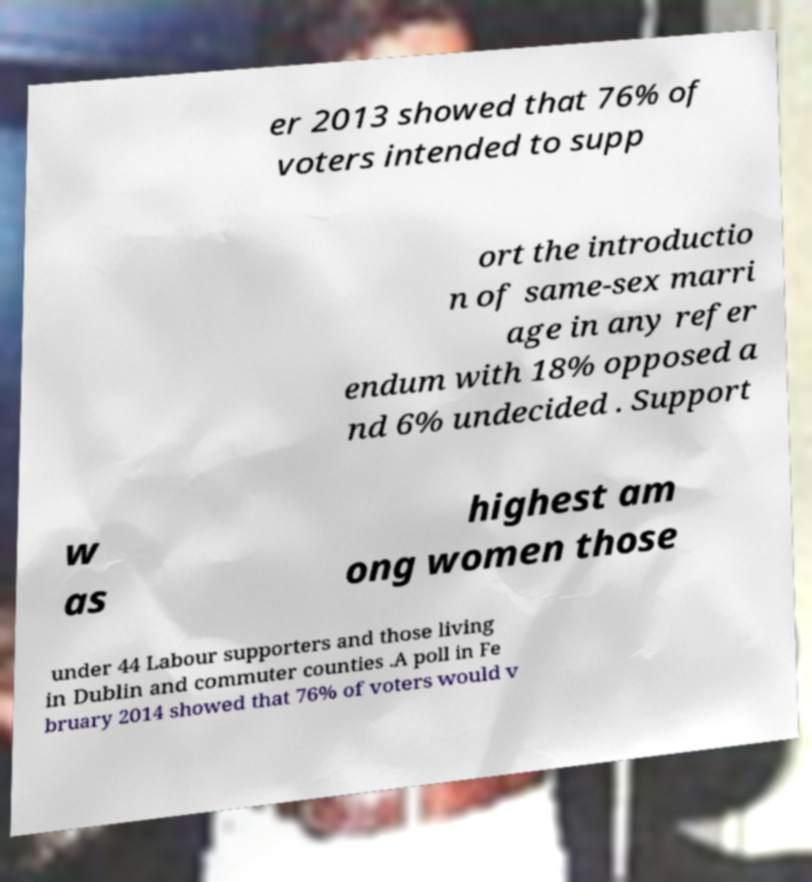Could you extract and type out the text from this image? er 2013 showed that 76% of voters intended to supp ort the introductio n of same-sex marri age in any refer endum with 18% opposed a nd 6% undecided . Support w as highest am ong women those under 44 Labour supporters and those living in Dublin and commuter counties .A poll in Fe bruary 2014 showed that 76% of voters would v 